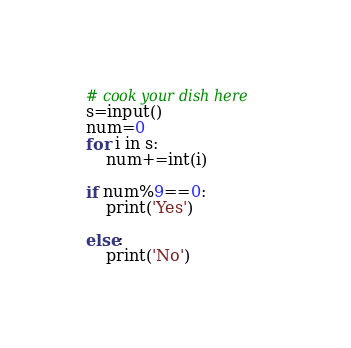Convert code to text. <code><loc_0><loc_0><loc_500><loc_500><_Python_># cook your dish here
s=input()
num=0
for i in s:
    num+=int(i)
    
if num%9==0:
    print('Yes')
    
else:
    print('No')</code> 